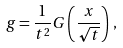Convert formula to latex. <formula><loc_0><loc_0><loc_500><loc_500>g = \frac { 1 } { t ^ { 2 } } G \left ( \frac { x } { \sqrt { t } } \right ) \, ,</formula> 